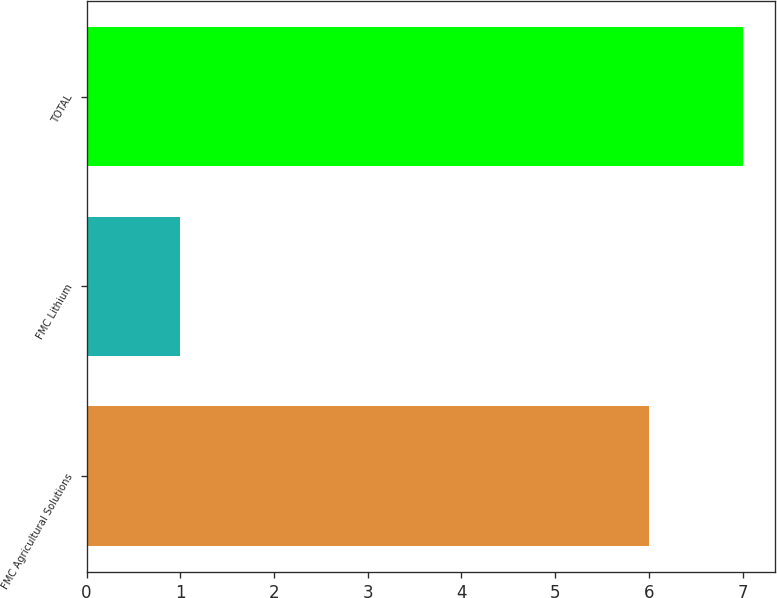Convert chart. <chart><loc_0><loc_0><loc_500><loc_500><bar_chart><fcel>FMC Agricultural Solutions<fcel>FMC Lithium<fcel>TOTAL<nl><fcel>6<fcel>1<fcel>7<nl></chart> 